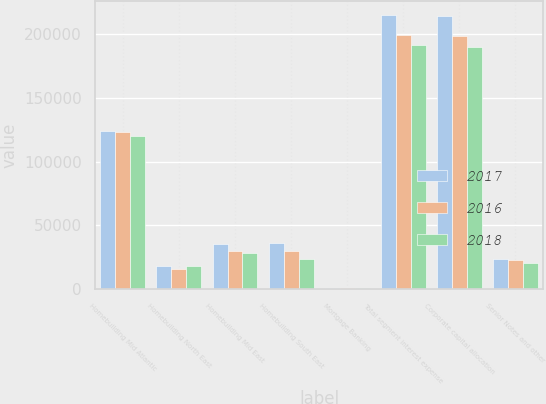Convert chart to OTSL. <chart><loc_0><loc_0><loc_500><loc_500><stacked_bar_chart><ecel><fcel>Homebuilding Mid Atlantic<fcel>Homebuilding North East<fcel>Homebuilding Mid East<fcel>Homebuilding South East<fcel>Mortgage Banking<fcel>Total segment interest expense<fcel>Corporate capital allocation<fcel>Senior Notes and other<nl><fcel>2017<fcel>123908<fcel>17897<fcel>35804<fcel>36362<fcel>1045<fcel>215016<fcel>213903<fcel>23968<nl><fcel>2016<fcel>123075<fcel>16117<fcel>29663<fcel>29583<fcel>1148<fcel>199586<fcel>198384<fcel>22983<nl><fcel>2018<fcel>119808<fcel>18141<fcel>28307<fcel>23804<fcel>1086<fcel>191146<fcel>189992<fcel>20553<nl></chart> 